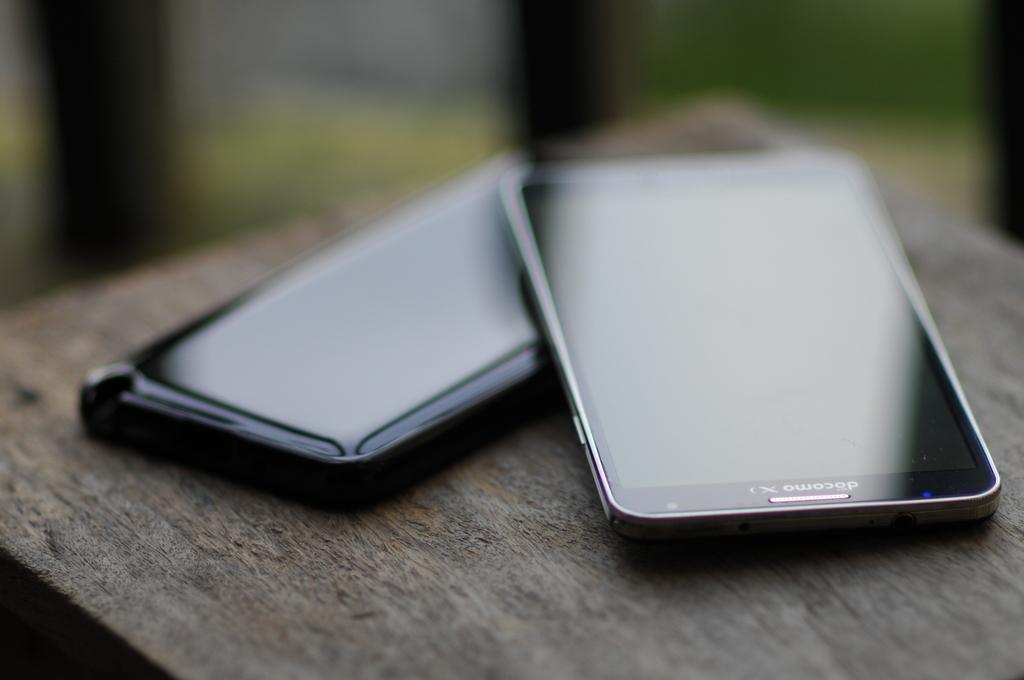What is the brand of smart phone?
Offer a terse response. Docomo. 